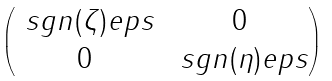<formula> <loc_0><loc_0><loc_500><loc_500>\begin{pmatrix} \ s g n ( \zeta ) e p s & 0 \\ 0 & \ s g n ( \eta ) e p s \end{pmatrix}</formula> 